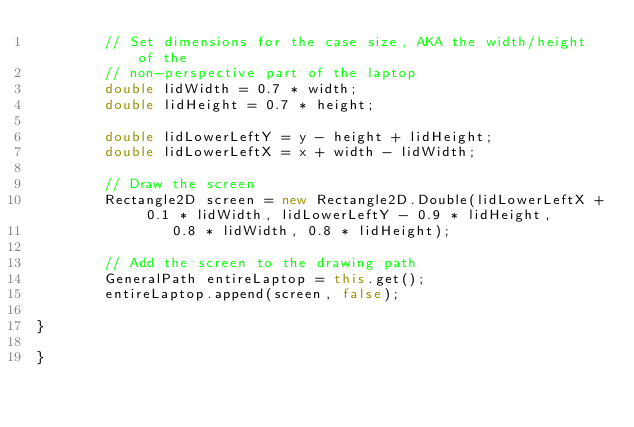<code> <loc_0><loc_0><loc_500><loc_500><_Java_>		// Set dimensions for the case size, AKA the width/height of the
		// non-perspective part of the laptop
		double lidWidth = 0.7 * width;
		double lidHeight = 0.7 * height;

		double lidLowerLeftY = y - height + lidHeight;
		double lidLowerLeftX = x + width - lidWidth;

		// Draw the screen
		Rectangle2D screen = new Rectangle2D.Double(lidLowerLeftX + 0.1 * lidWidth, lidLowerLeftY - 0.9 * lidHeight,
				0.8 * lidWidth,	0.8 * lidHeight);

		// Add the screen to the drawing path
		GeneralPath entireLaptop = this.get();
		entireLaptop.append(screen, false);

}

}
</code> 